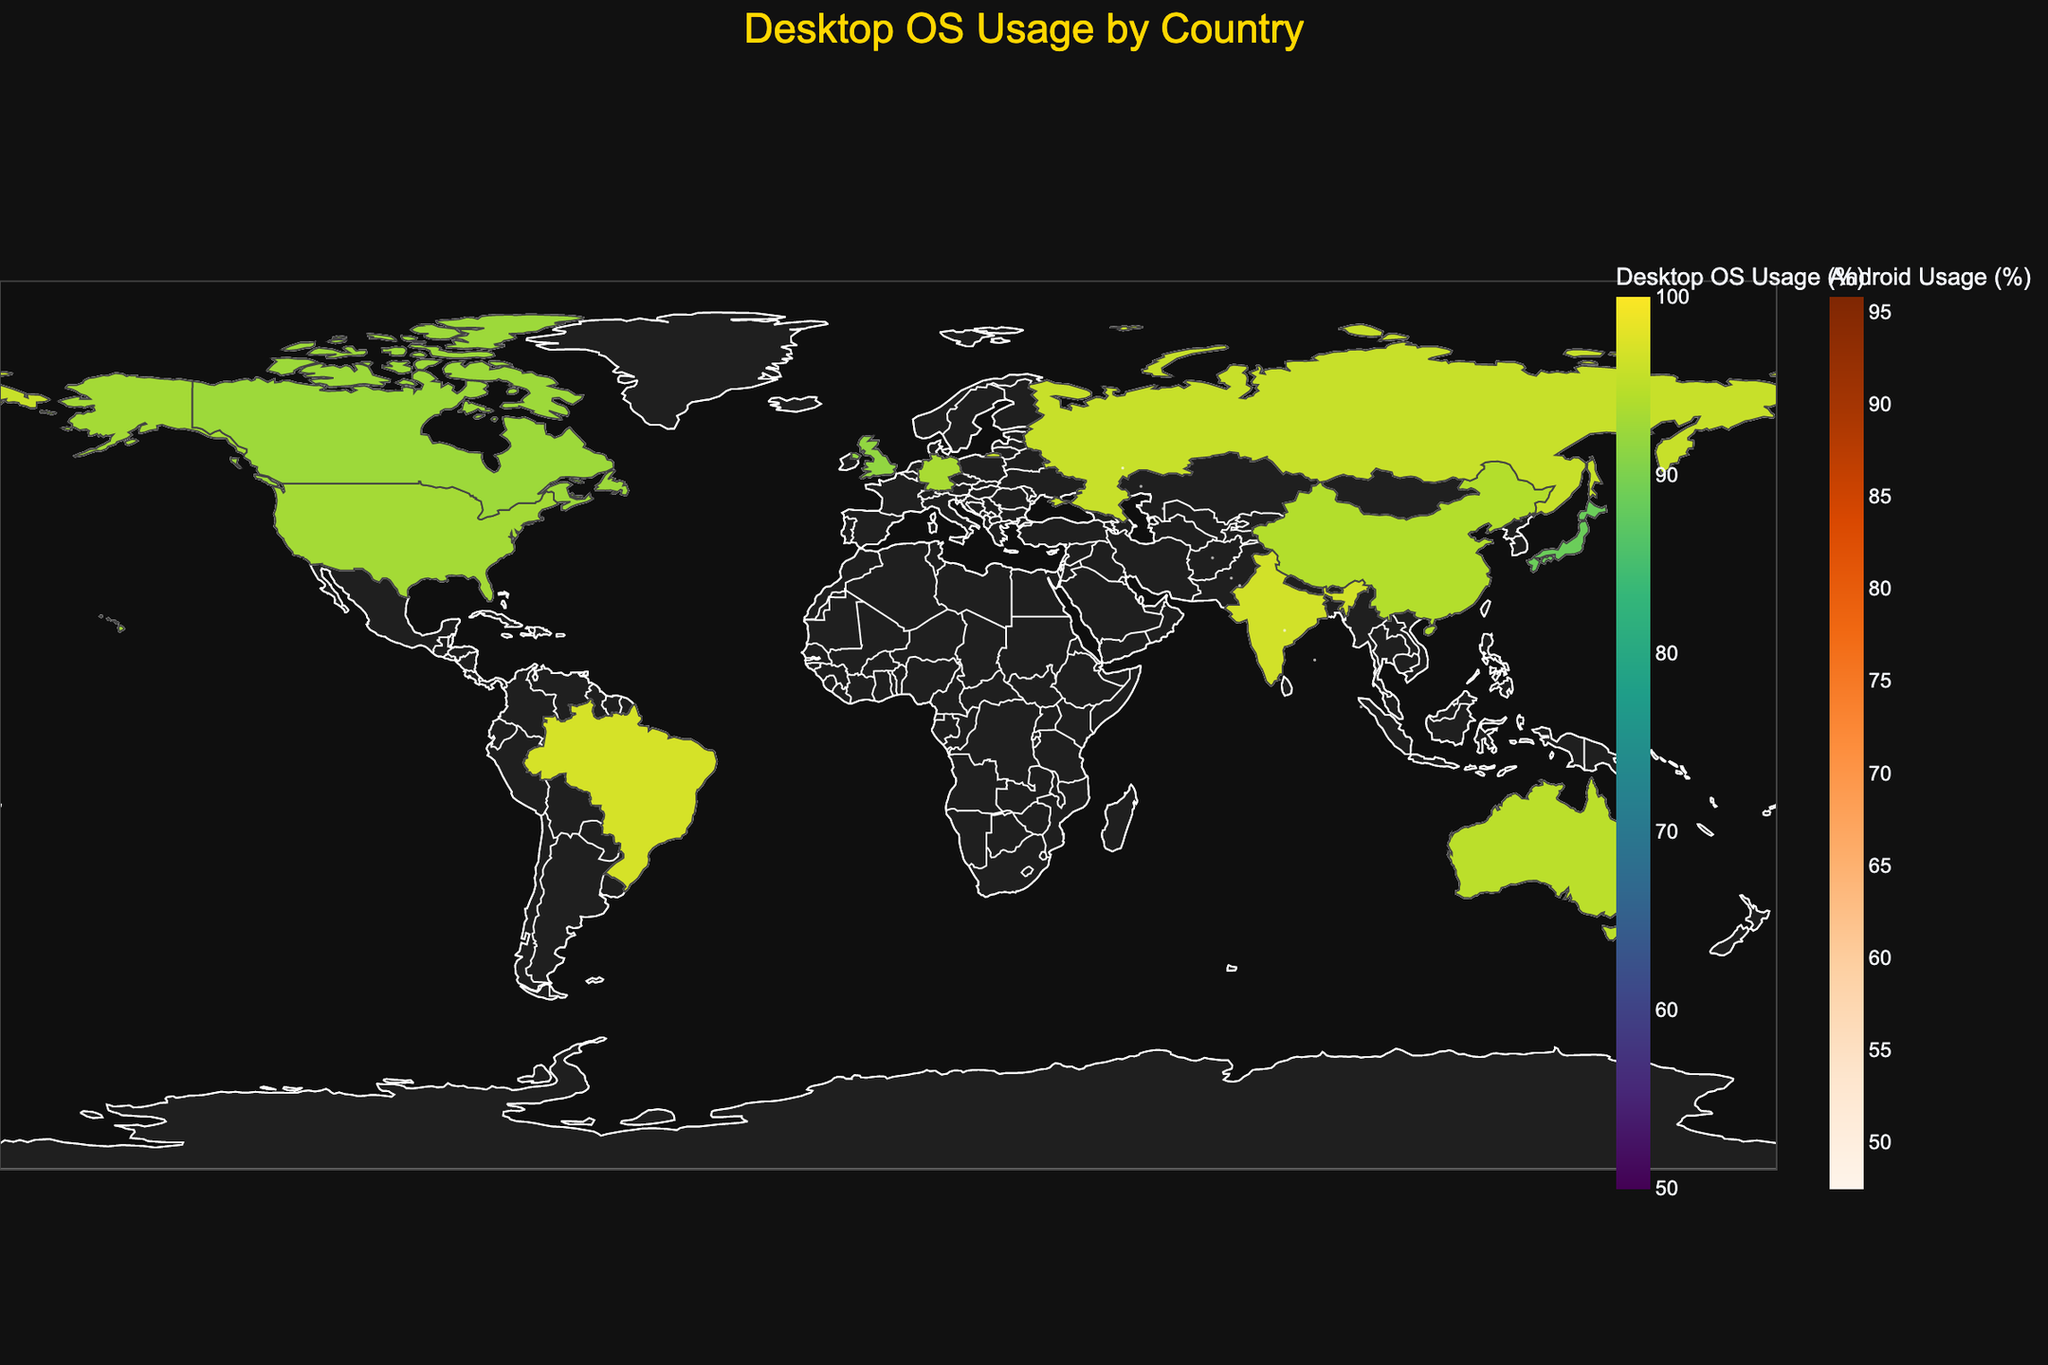What is the title of the figure? The title is typically displayed at the top of the figure. By looking at the figure, the title reads "Desktop OS Usage by Country".
Answer: Desktop OS Usage by Country What color scale is used for the desktop OS usage? The figure uses the 'Viridis' color scale for the desktop OS usage, which ranges from green to yellow. You can identify this by the gradient color bar indicating 'Desktop OS Usage (%)'.
Answer: Viridis Which country has the highest desktop OS usage? By comparing the color intensity on the map, China has the highest desktop OS usage shown with the darkest color, indicating the highest value based on the scale provided.
Answer: China For which country does Android have the highest usage in mobile OS? By examining the size of the bubbles, India has the largest bubble representing mobile OS usage, and the color scale also indicates high Android usage as shown by the orange color.
Answer: India How does the mobile iOS usage compare between the United States and Japan? By analyzing the bubbles positioned based on percentage usage along the axes, the United States has a higher mobile iOS usage percentage (52.1%) compared to Japan (33.9%).
Answer: The United States has higher usage What is the difference in desktop Windows usage between Germany and the United Kingdom? Germany has 77.4% and the United Kingdom has 70.1% desktop Windows usage. The difference is 77.4% - 70.1% = 7.3%.
Answer: 7.3% What is the total percentage of mobile OS usage in Brazil? The total mobile OS usage is the sum of Mobile Android (86.4%) and Mobile iOS (13.2%). Thus, 86.4% + 13.2% = 99.6%.
Answer: 99.6% Which country has the highest combined desktop and mobile OS usage? By adding the combined desktop and mobile OS usage (sum of Desktop Total and Mobile Total for each country), India stands out with two high values for Desktop (91.2%) and Mobile (95.8%).
Answer: India How does the representation of desktop macOS usage visually differ across countries? The variations in the color scale across countries indicate different levels of desktop macOS usage, with the darkest regions showing higher values, prominently in the United States and Canada where the desktop macOS usage percentage is around 25.8% and 27.3% respectively.
Answer: Higher in the United States and Canada What is the median value of desktop Linux usage among all countries presented? The desktop Linux usage values are 2.1, 1.5, 1.8, 3.5, 2.7, 1.9, 2.3, 4.2, 2.5, 2.9. Ordering these values (1.5, 1.8, 1.9, 2.1, 2.3, 2.5, 2.7, 2.9, 3.5, 4.2), the median is the middle value in a sorted list of numbers, so the median is (2.3 + 2.5)/2 = 2.4.
Answer: 2.4 